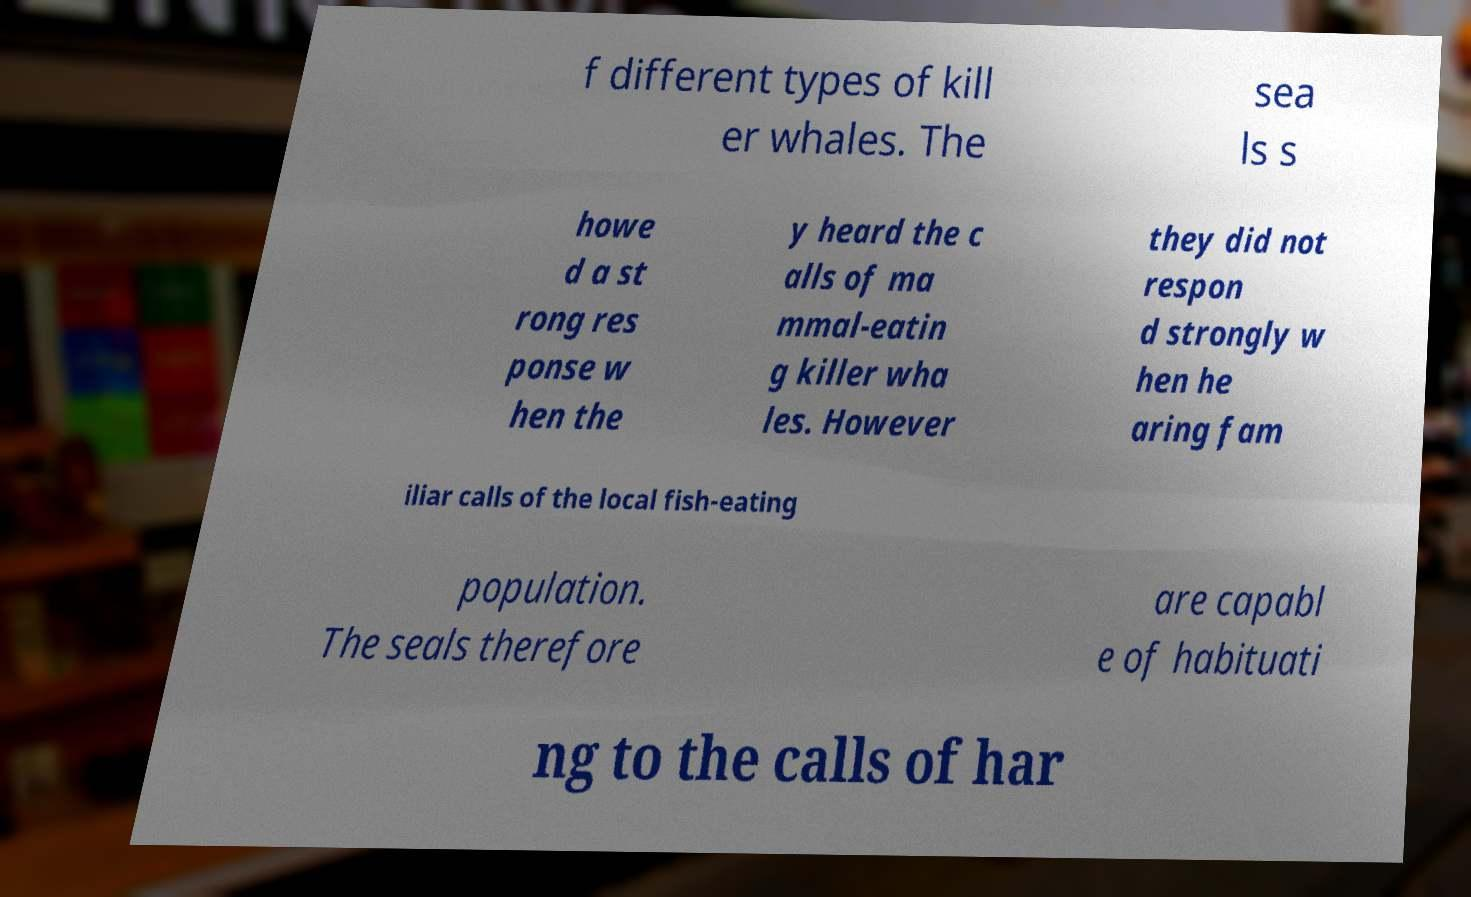There's text embedded in this image that I need extracted. Can you transcribe it verbatim? f different types of kill er whales. The sea ls s howe d a st rong res ponse w hen the y heard the c alls of ma mmal-eatin g killer wha les. However they did not respon d strongly w hen he aring fam iliar calls of the local fish-eating population. The seals therefore are capabl e of habituati ng to the calls of har 